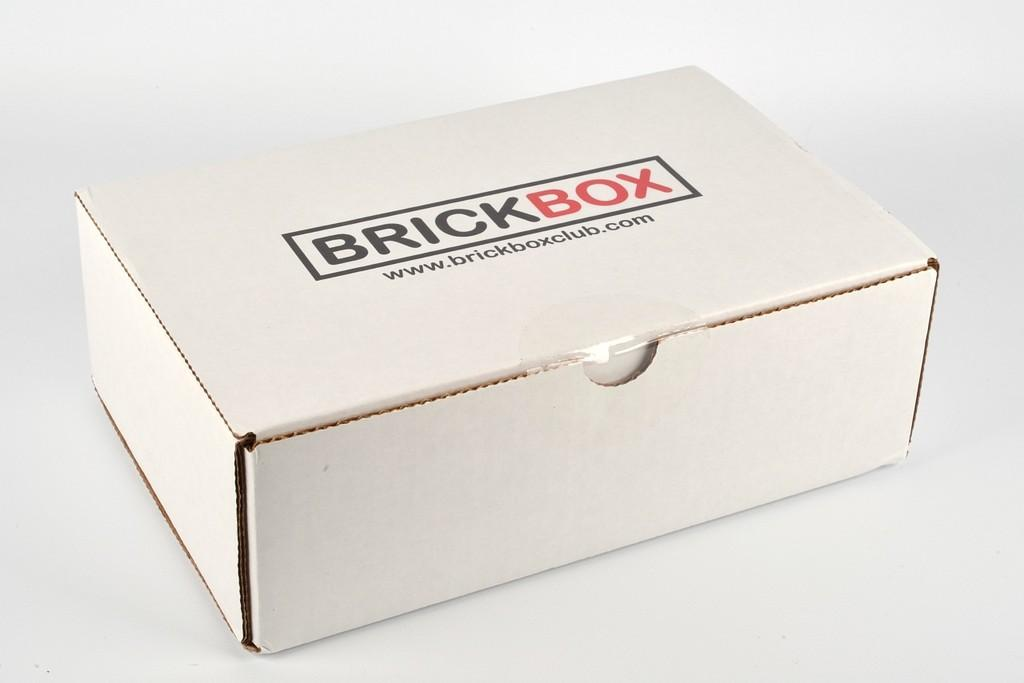Provide a one-sentence caption for the provided image. BRICKBOX is printed on a white box that lays by itself. 